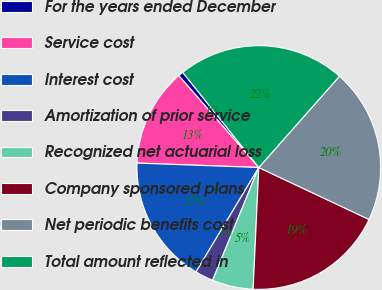Convert chart to OTSL. <chart><loc_0><loc_0><loc_500><loc_500><pie_chart><fcel>For the years ended December<fcel>Service cost<fcel>Interest cost<fcel>Amortization of prior service<fcel>Recognized net actuarial loss<fcel>Company sponsored plans<fcel>Net periodic benefits cost<fcel>Total amount reflected in<nl><fcel>0.67%<fcel>13.02%<fcel>16.96%<fcel>2.43%<fcel>5.45%<fcel>18.73%<fcel>20.49%<fcel>22.25%<nl></chart> 